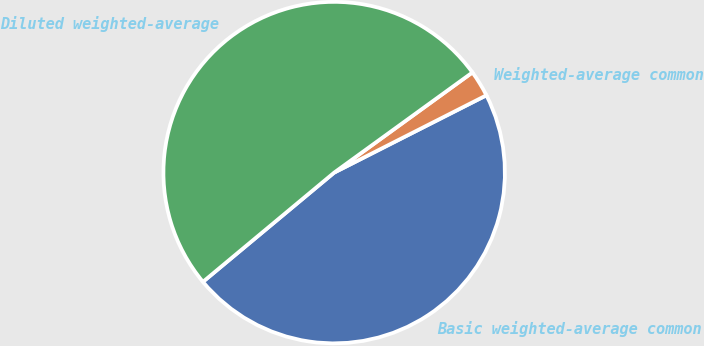Convert chart to OTSL. <chart><loc_0><loc_0><loc_500><loc_500><pie_chart><fcel>Basic weighted-average common<fcel>Weighted-average common<fcel>Diluted weighted-average<nl><fcel>46.43%<fcel>2.5%<fcel>51.07%<nl></chart> 